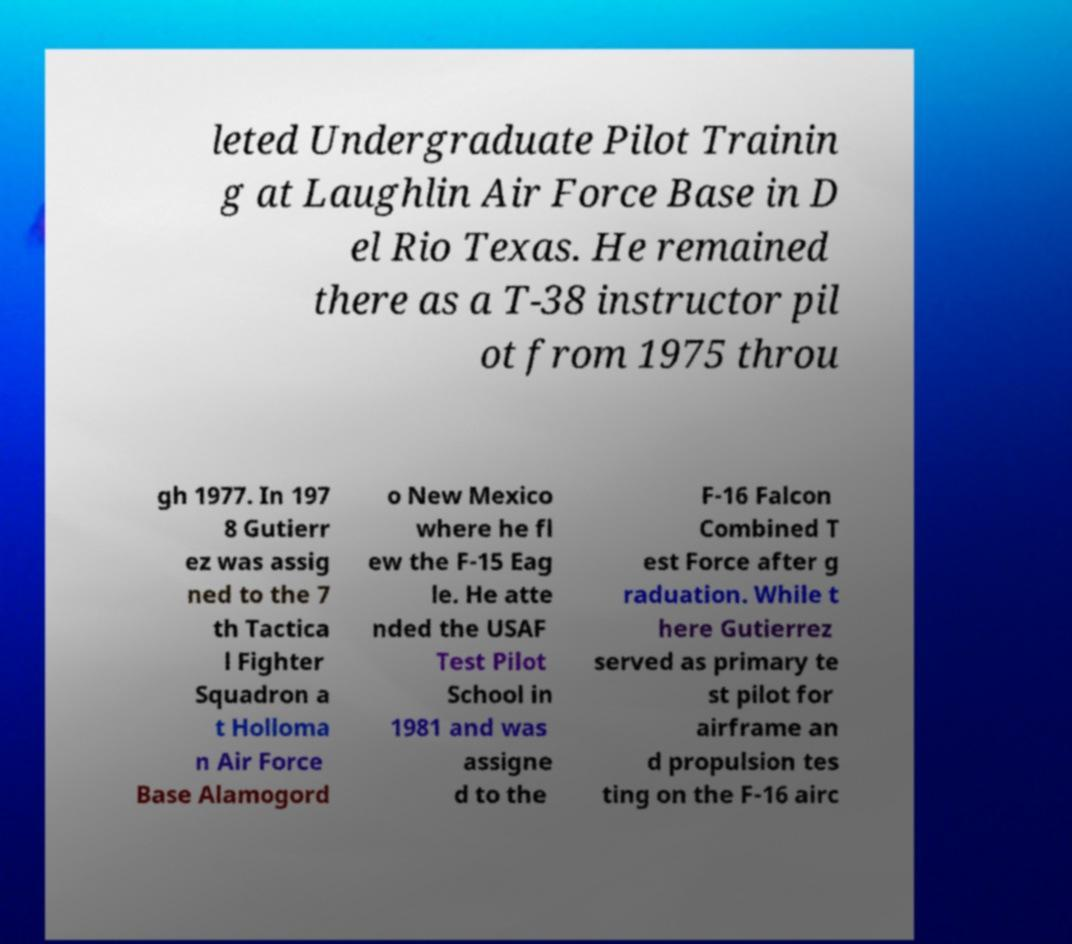Could you extract and type out the text from this image? leted Undergraduate Pilot Trainin g at Laughlin Air Force Base in D el Rio Texas. He remained there as a T-38 instructor pil ot from 1975 throu gh 1977. In 197 8 Gutierr ez was assig ned to the 7 th Tactica l Fighter Squadron a t Holloma n Air Force Base Alamogord o New Mexico where he fl ew the F-15 Eag le. He atte nded the USAF Test Pilot School in 1981 and was assigne d to the F-16 Falcon Combined T est Force after g raduation. While t here Gutierrez served as primary te st pilot for airframe an d propulsion tes ting on the F-16 airc 